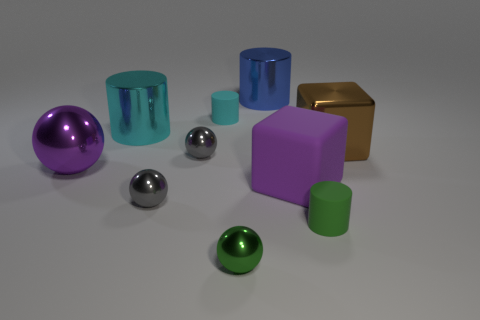Subtract 1 spheres. How many spheres are left? 3 Subtract all yellow cubes. Subtract all purple cylinders. How many cubes are left? 2 Subtract all balls. How many objects are left? 6 Add 5 small gray spheres. How many small gray spheres are left? 7 Add 2 purple balls. How many purple balls exist? 3 Subtract 0 gray cylinders. How many objects are left? 10 Subtract all gray metallic balls. Subtract all balls. How many objects are left? 4 